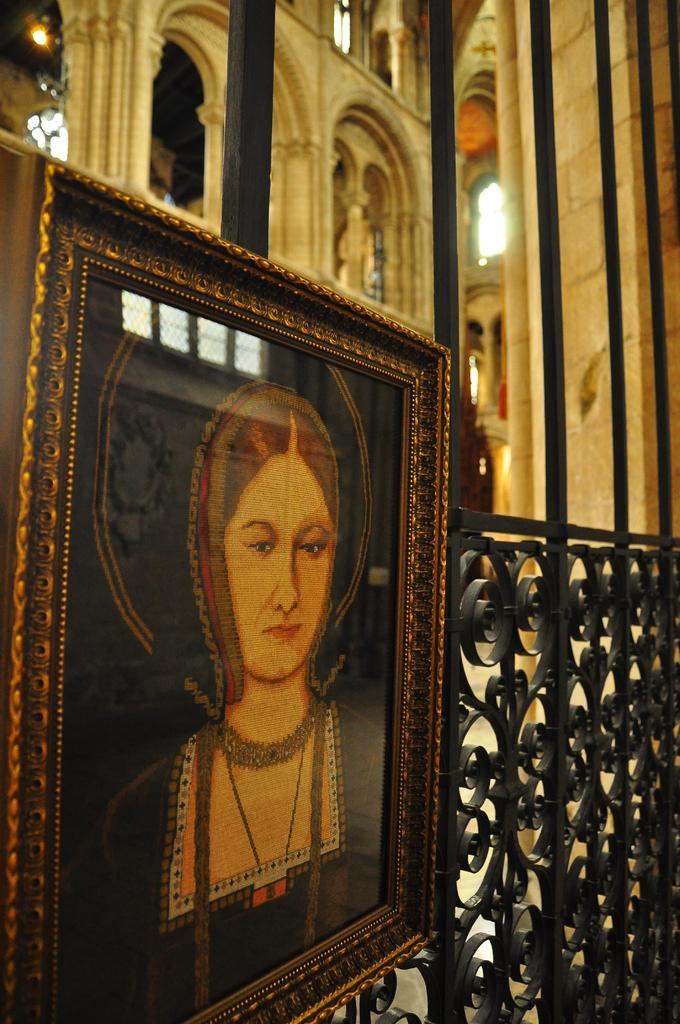What object is present in the image that typically holds a photograph? There is a photo frame in the image. Where is the photo frame located? The photo frame is on a railing. What can be seen in the distance behind the photo frame? There is a building visible in the background of the image. How many cups are placed on the sheet in the image? There are no cups or sheets present in the image; it only features a photo frame on a railing with a building in the background. 